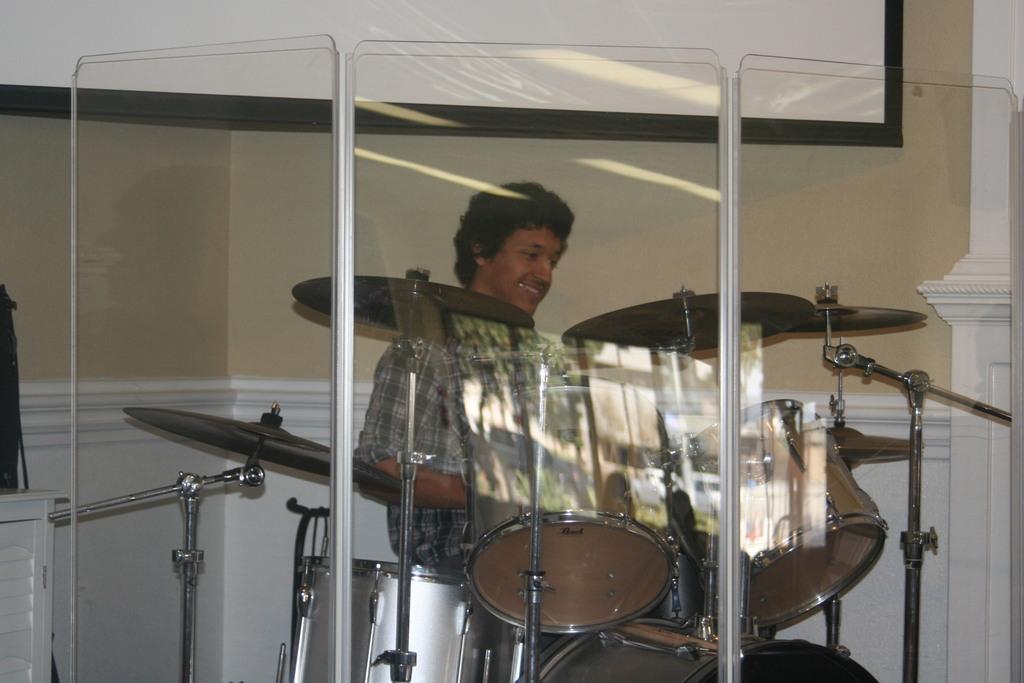How would you summarize this image in a sentence or two? In this image, we can see a person sitting, we can see some musical instruments, in the background, we can see the wall and a poster on the wall. 